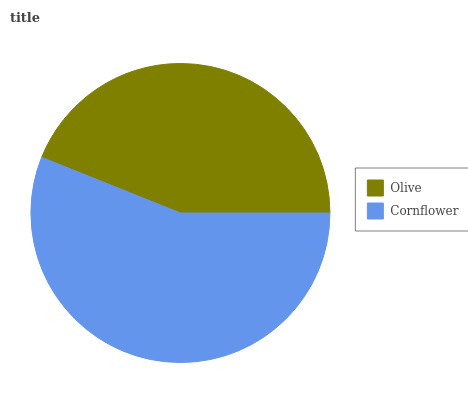Is Olive the minimum?
Answer yes or no. Yes. Is Cornflower the maximum?
Answer yes or no. Yes. Is Cornflower the minimum?
Answer yes or no. No. Is Cornflower greater than Olive?
Answer yes or no. Yes. Is Olive less than Cornflower?
Answer yes or no. Yes. Is Olive greater than Cornflower?
Answer yes or no. No. Is Cornflower less than Olive?
Answer yes or no. No. Is Cornflower the high median?
Answer yes or no. Yes. Is Olive the low median?
Answer yes or no. Yes. Is Olive the high median?
Answer yes or no. No. Is Cornflower the low median?
Answer yes or no. No. 